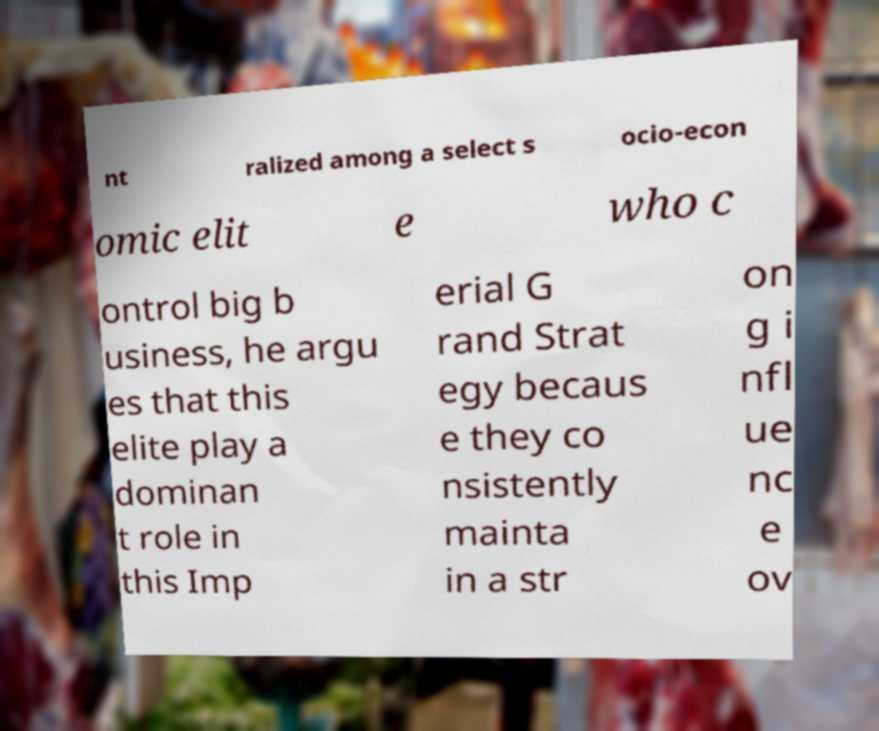I need the written content from this picture converted into text. Can you do that? nt ralized among a select s ocio-econ omic elit e who c ontrol big b usiness, he argu es that this elite play a dominan t role in this Imp erial G rand Strat egy becaus e they co nsistently mainta in a str on g i nfl ue nc e ov 